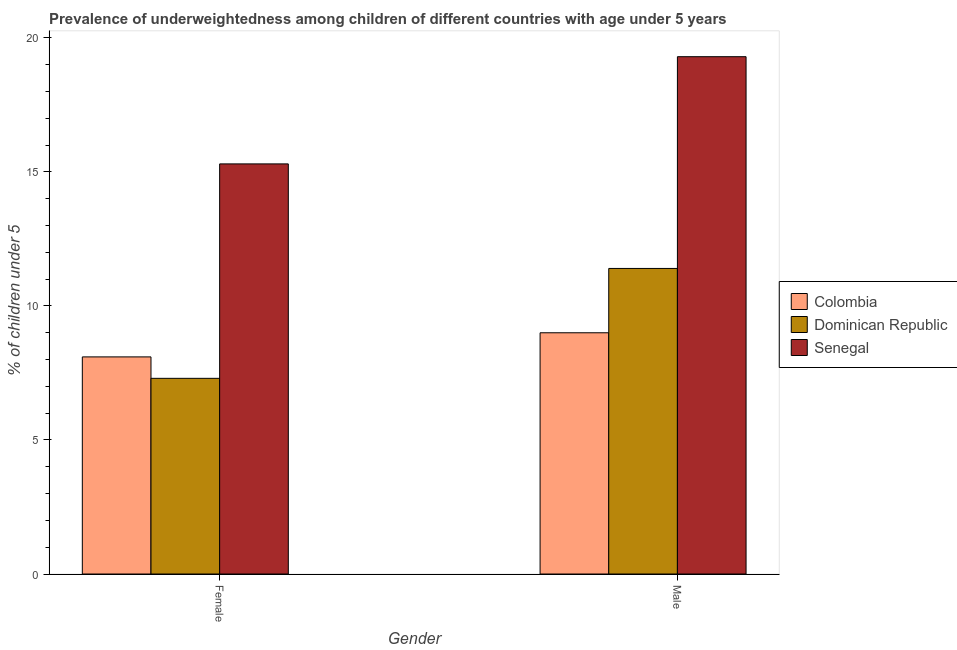How many different coloured bars are there?
Ensure brevity in your answer.  3. How many groups of bars are there?
Your answer should be very brief. 2. Are the number of bars per tick equal to the number of legend labels?
Keep it short and to the point. Yes. Are the number of bars on each tick of the X-axis equal?
Give a very brief answer. Yes. What is the percentage of underweighted female children in Colombia?
Keep it short and to the point. 8.1. Across all countries, what is the maximum percentage of underweighted male children?
Make the answer very short. 19.3. Across all countries, what is the minimum percentage of underweighted female children?
Your answer should be very brief. 7.3. In which country was the percentage of underweighted male children maximum?
Make the answer very short. Senegal. In which country was the percentage of underweighted female children minimum?
Provide a succinct answer. Dominican Republic. What is the total percentage of underweighted female children in the graph?
Provide a short and direct response. 30.7. What is the difference between the percentage of underweighted male children in Colombia and that in Senegal?
Your answer should be very brief. -10.3. What is the difference between the percentage of underweighted female children in Dominican Republic and the percentage of underweighted male children in Colombia?
Provide a succinct answer. -1.7. What is the average percentage of underweighted male children per country?
Provide a succinct answer. 13.23. What is the difference between the percentage of underweighted male children and percentage of underweighted female children in Senegal?
Your answer should be compact. 4. In how many countries, is the percentage of underweighted male children greater than 5 %?
Provide a succinct answer. 3. What is the ratio of the percentage of underweighted male children in Dominican Republic to that in Colombia?
Give a very brief answer. 1.27. What does the 2nd bar from the left in Female represents?
Make the answer very short. Dominican Republic. How many countries are there in the graph?
Provide a succinct answer. 3. Does the graph contain any zero values?
Your answer should be very brief. No. Does the graph contain grids?
Your answer should be compact. No. Where does the legend appear in the graph?
Offer a terse response. Center right. How are the legend labels stacked?
Ensure brevity in your answer.  Vertical. What is the title of the graph?
Your answer should be compact. Prevalence of underweightedness among children of different countries with age under 5 years. What is the label or title of the Y-axis?
Ensure brevity in your answer.   % of children under 5. What is the  % of children under 5 in Colombia in Female?
Your answer should be compact. 8.1. What is the  % of children under 5 of Dominican Republic in Female?
Your answer should be compact. 7.3. What is the  % of children under 5 in Senegal in Female?
Make the answer very short. 15.3. What is the  % of children under 5 of Dominican Republic in Male?
Keep it short and to the point. 11.4. What is the  % of children under 5 in Senegal in Male?
Ensure brevity in your answer.  19.3. Across all Gender, what is the maximum  % of children under 5 of Colombia?
Make the answer very short. 9. Across all Gender, what is the maximum  % of children under 5 in Dominican Republic?
Make the answer very short. 11.4. Across all Gender, what is the maximum  % of children under 5 of Senegal?
Offer a terse response. 19.3. Across all Gender, what is the minimum  % of children under 5 in Colombia?
Keep it short and to the point. 8.1. Across all Gender, what is the minimum  % of children under 5 of Dominican Republic?
Your answer should be compact. 7.3. Across all Gender, what is the minimum  % of children under 5 in Senegal?
Offer a very short reply. 15.3. What is the total  % of children under 5 of Dominican Republic in the graph?
Offer a terse response. 18.7. What is the total  % of children under 5 in Senegal in the graph?
Keep it short and to the point. 34.6. What is the difference between the  % of children under 5 in Colombia in Female and that in Male?
Make the answer very short. -0.9. What is the difference between the  % of children under 5 in Senegal in Female and that in Male?
Offer a terse response. -4. What is the average  % of children under 5 of Colombia per Gender?
Keep it short and to the point. 8.55. What is the average  % of children under 5 in Dominican Republic per Gender?
Offer a very short reply. 9.35. What is the difference between the  % of children under 5 in Colombia and  % of children under 5 in Dominican Republic in Male?
Offer a very short reply. -2.4. What is the difference between the  % of children under 5 of Colombia and  % of children under 5 of Senegal in Male?
Your response must be concise. -10.3. What is the difference between the  % of children under 5 in Dominican Republic and  % of children under 5 in Senegal in Male?
Your answer should be very brief. -7.9. What is the ratio of the  % of children under 5 in Dominican Republic in Female to that in Male?
Your answer should be very brief. 0.64. What is the ratio of the  % of children under 5 in Senegal in Female to that in Male?
Provide a succinct answer. 0.79. What is the difference between the highest and the second highest  % of children under 5 in Colombia?
Give a very brief answer. 0.9. What is the difference between the highest and the second highest  % of children under 5 in Senegal?
Offer a terse response. 4. What is the difference between the highest and the lowest  % of children under 5 in Colombia?
Give a very brief answer. 0.9. What is the difference between the highest and the lowest  % of children under 5 in Dominican Republic?
Ensure brevity in your answer.  4.1. What is the difference between the highest and the lowest  % of children under 5 in Senegal?
Offer a terse response. 4. 